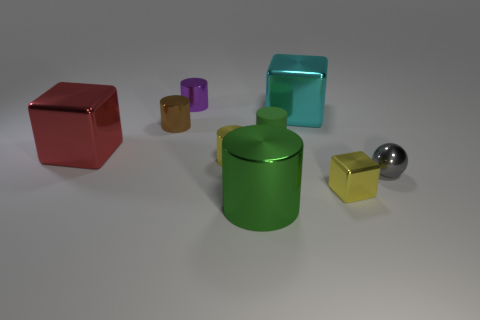There is a red object that is the same material as the brown object; what is its size?
Offer a terse response. Large. Do the rubber object and the large object in front of the small yellow metallic cylinder have the same color?
Make the answer very short. Yes. There is a small thing that is right of the small yellow cylinder and to the left of the cyan metallic thing; what material is it?
Offer a terse response. Rubber. What is the size of the metal cylinder that is the same color as the tiny metal cube?
Your response must be concise. Small. There is a tiny yellow metal thing that is in front of the small gray metallic thing; is its shape the same as the big object behind the red metallic object?
Your answer should be compact. Yes. Are any tiny metal cubes visible?
Your answer should be compact. Yes. There is a big metal thing that is the same shape as the small matte thing; what is its color?
Your answer should be very brief. Green. The rubber thing that is the same size as the yellow block is what color?
Offer a very short reply. Green. Do the brown thing and the small green object have the same material?
Offer a very short reply. No. What number of metallic cubes are the same color as the rubber thing?
Your answer should be very brief. 0. 